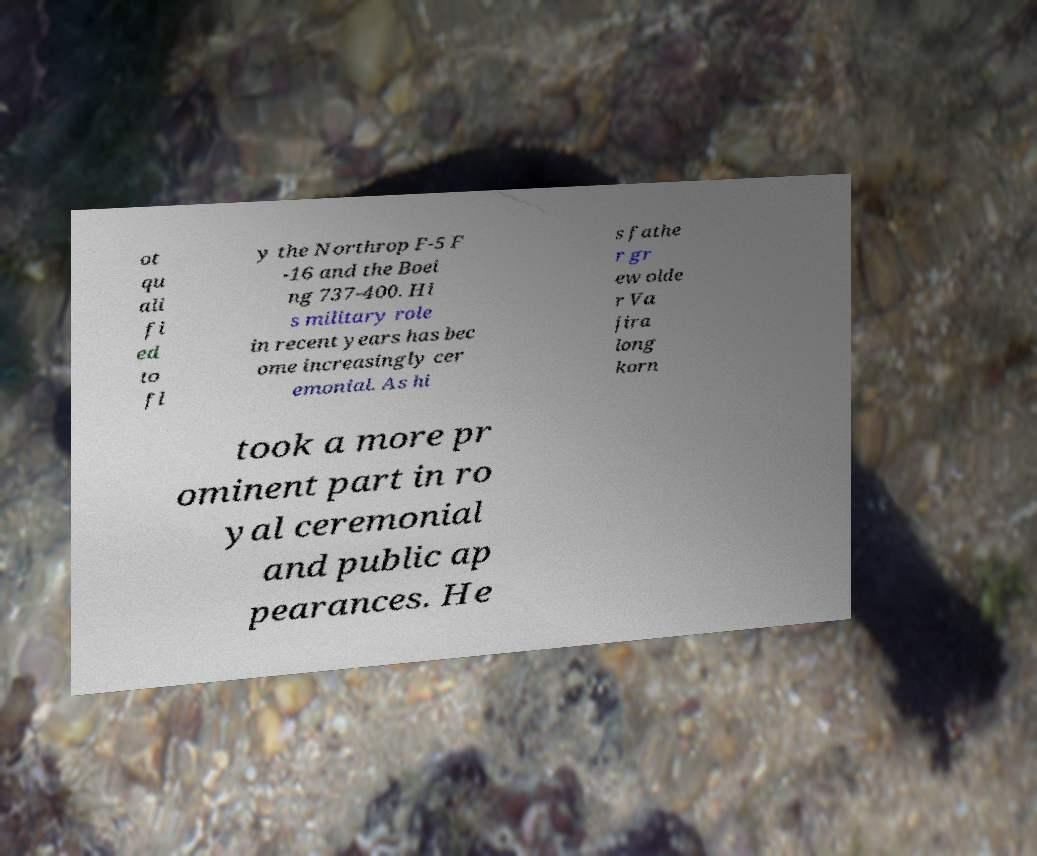Please identify and transcribe the text found in this image. ot qu ali fi ed to fl y the Northrop F-5 F -16 and the Boei ng 737-400. Hi s military role in recent years has bec ome increasingly cer emonial. As hi s fathe r gr ew olde r Va jira long korn took a more pr ominent part in ro yal ceremonial and public ap pearances. He 